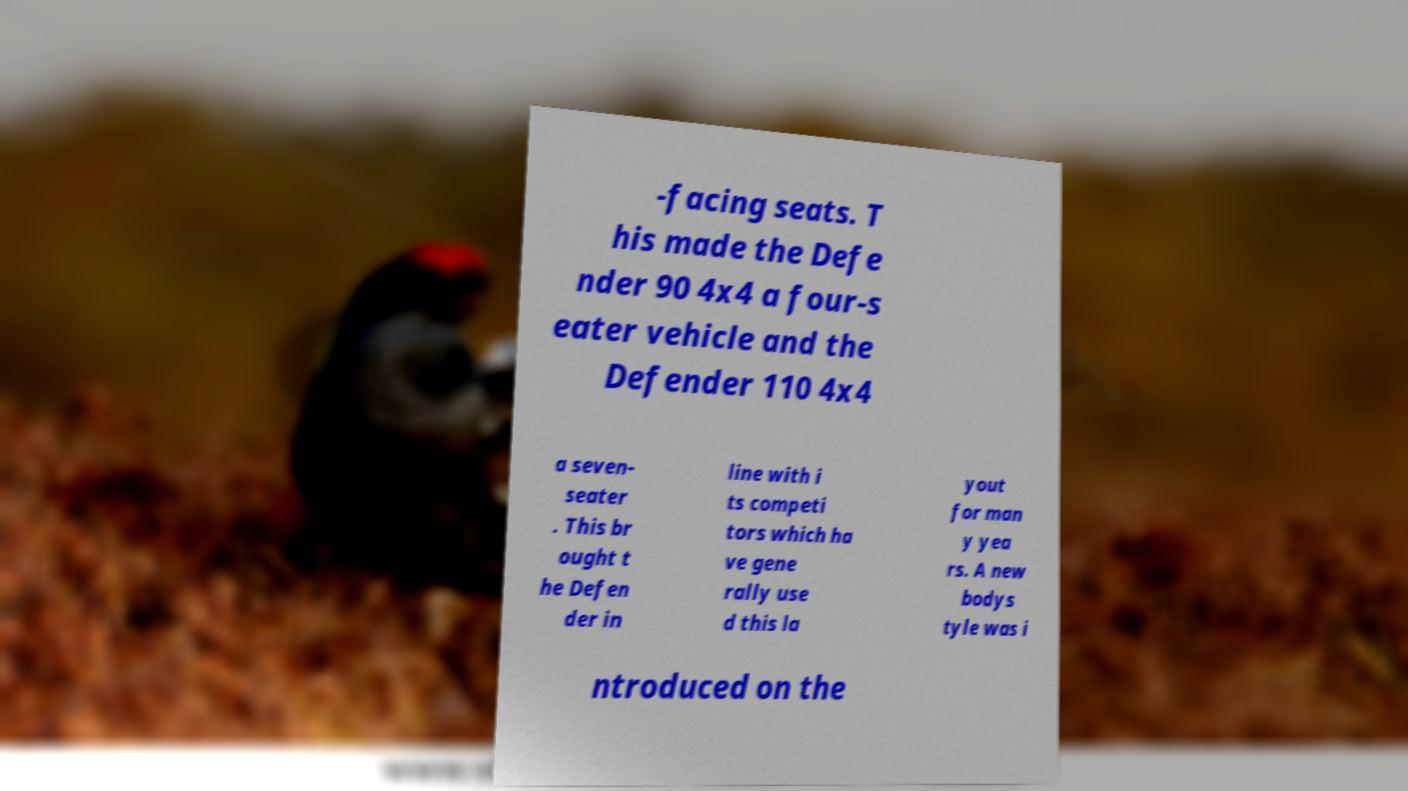Can you read and provide the text displayed in the image?This photo seems to have some interesting text. Can you extract and type it out for me? -facing seats. T his made the Defe nder 90 4x4 a four-s eater vehicle and the Defender 110 4x4 a seven- seater . This br ought t he Defen der in line with i ts competi tors which ha ve gene rally use d this la yout for man y yea rs. A new bodys tyle was i ntroduced on the 